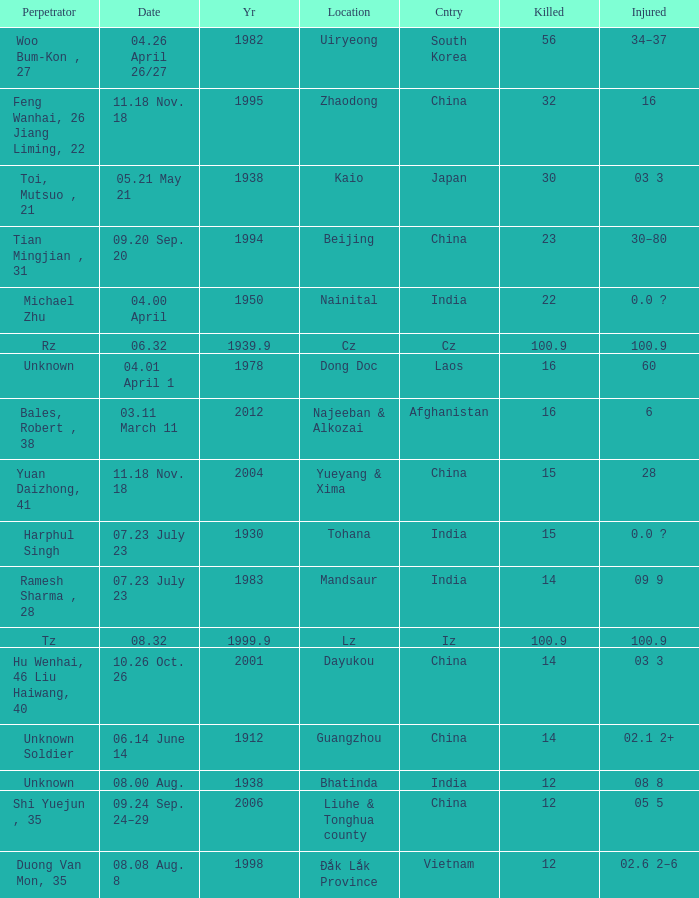What is Date, when Country is "China", and when Perpetrator is "Shi Yuejun , 35"? 09.24 Sep. 24–29. 